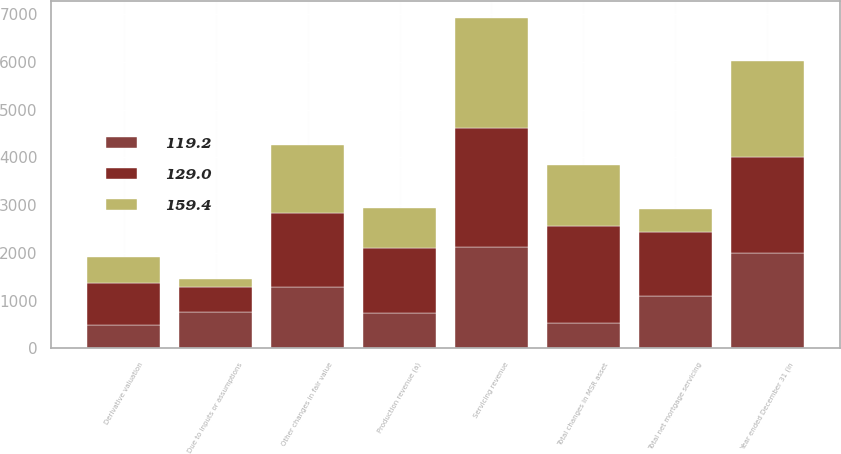Convert chart to OTSL. <chart><loc_0><loc_0><loc_500><loc_500><stacked_bar_chart><ecel><fcel>Year ended December 31 (in<fcel>Production revenue (a)<fcel>Servicing revenue<fcel>Due to inputs or assumptions<fcel>Other changes in fair value<fcel>Total changes in MSR asset<fcel>Derivative valuation<fcel>Total net mortgage servicing<nl><fcel>129<fcel>2007<fcel>1360<fcel>2510<fcel>516<fcel>1531<fcel>2047<fcel>879<fcel>1342<nl><fcel>159.4<fcel>2006<fcel>833<fcel>2300<fcel>165<fcel>1440<fcel>1275<fcel>544<fcel>481<nl><fcel>119.2<fcel>2005<fcel>744<fcel>2115<fcel>770<fcel>1295<fcel>525<fcel>494<fcel>1096<nl></chart> 